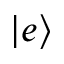Convert formula to latex. <formula><loc_0><loc_0><loc_500><loc_500>| e \rangle</formula> 